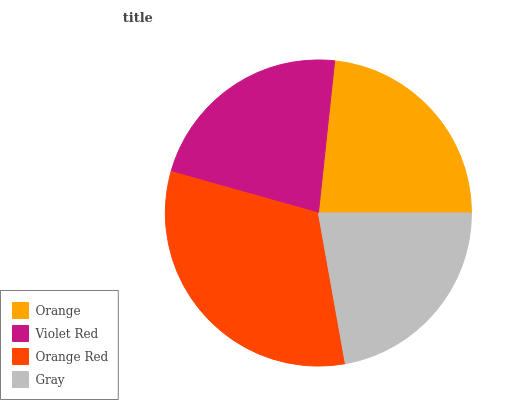Is Gray the minimum?
Answer yes or no. Yes. Is Orange Red the maximum?
Answer yes or no. Yes. Is Violet Red the minimum?
Answer yes or no. No. Is Violet Red the maximum?
Answer yes or no. No. Is Orange greater than Violet Red?
Answer yes or no. Yes. Is Violet Red less than Orange?
Answer yes or no. Yes. Is Violet Red greater than Orange?
Answer yes or no. No. Is Orange less than Violet Red?
Answer yes or no. No. Is Orange the high median?
Answer yes or no. Yes. Is Violet Red the low median?
Answer yes or no. Yes. Is Gray the high median?
Answer yes or no. No. Is Orange the low median?
Answer yes or no. No. 